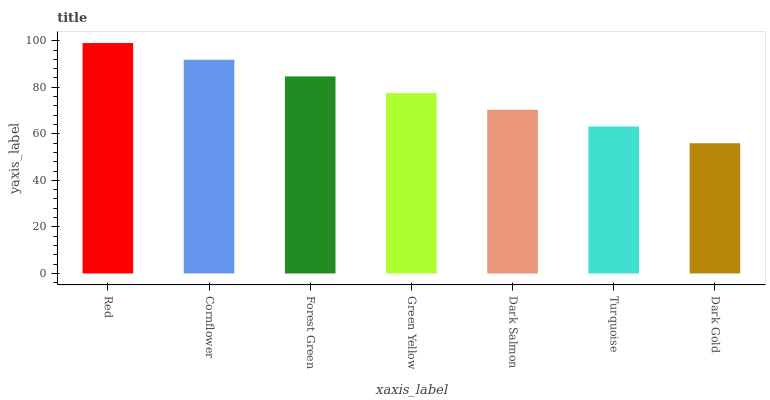Is Dark Gold the minimum?
Answer yes or no. Yes. Is Red the maximum?
Answer yes or no. Yes. Is Cornflower the minimum?
Answer yes or no. No. Is Cornflower the maximum?
Answer yes or no. No. Is Red greater than Cornflower?
Answer yes or no. Yes. Is Cornflower less than Red?
Answer yes or no. Yes. Is Cornflower greater than Red?
Answer yes or no. No. Is Red less than Cornflower?
Answer yes or no. No. Is Green Yellow the high median?
Answer yes or no. Yes. Is Green Yellow the low median?
Answer yes or no. Yes. Is Forest Green the high median?
Answer yes or no. No. Is Dark Salmon the low median?
Answer yes or no. No. 